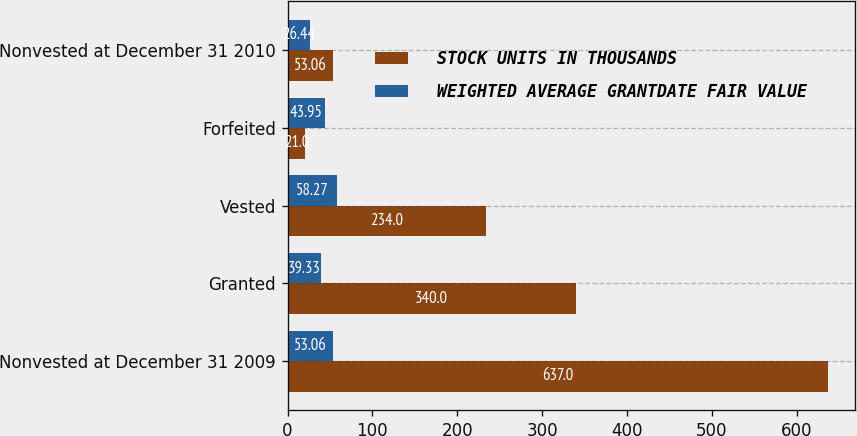Convert chart to OTSL. <chart><loc_0><loc_0><loc_500><loc_500><stacked_bar_chart><ecel><fcel>Nonvested at December 31 2009<fcel>Granted<fcel>Vested<fcel>Forfeited<fcel>Nonvested at December 31 2010<nl><fcel>STOCK UNITS IN THOUSANDS<fcel>637<fcel>340<fcel>234<fcel>21<fcel>53.06<nl><fcel>WEIGHTED AVERAGE GRANTDATE FAIR VALUE<fcel>53.06<fcel>39.33<fcel>58.27<fcel>43.95<fcel>26.44<nl></chart> 